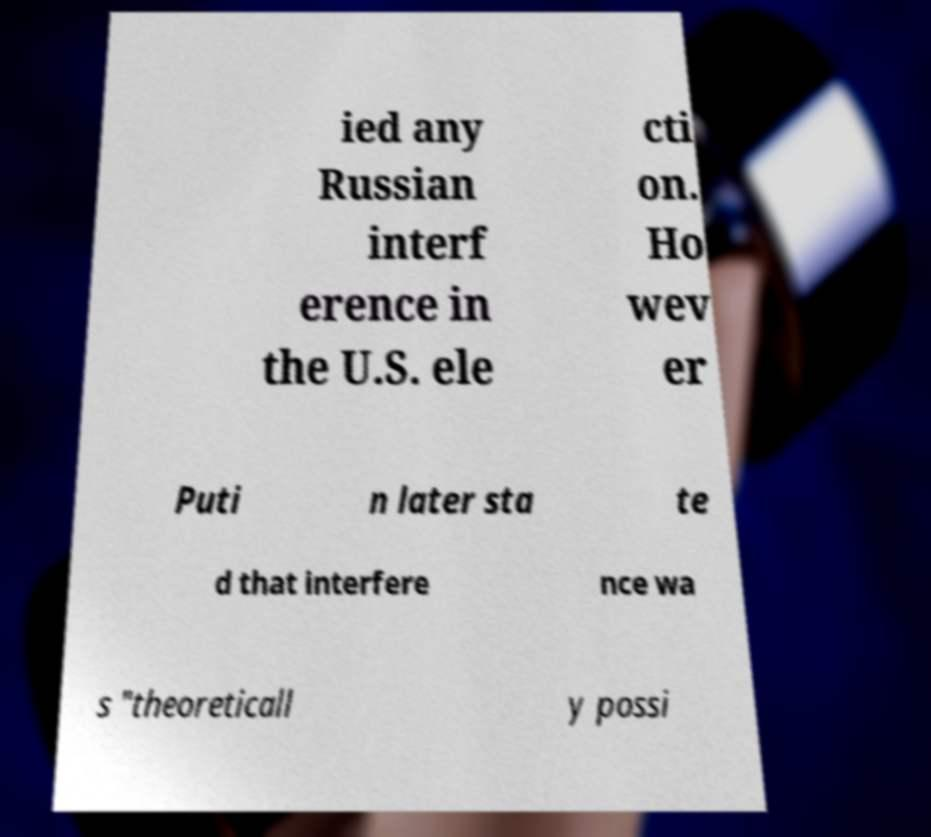Could you assist in decoding the text presented in this image and type it out clearly? ied any Russian interf erence in the U.S. ele cti on. Ho wev er Puti n later sta te d that interfere nce wa s "theoreticall y possi 